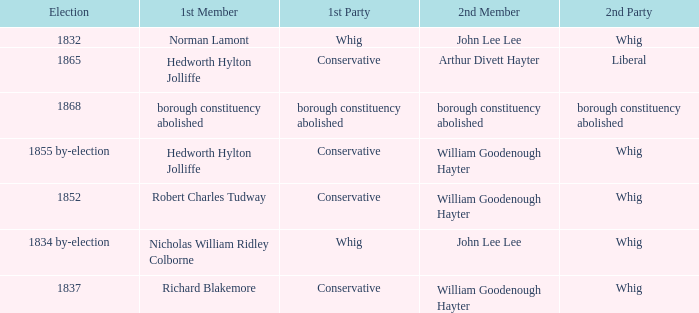Who's the conservative 1st member of the election of 1852? Robert Charles Tudway. I'm looking to parse the entire table for insights. Could you assist me with that? {'header': ['Election', '1st Member', '1st Party', '2nd Member', '2nd Party'], 'rows': [['1832', 'Norman Lamont', 'Whig', 'John Lee Lee', 'Whig'], ['1865', 'Hedworth Hylton Jolliffe', 'Conservative', 'Arthur Divett Hayter', 'Liberal'], ['1868', 'borough constituency abolished', 'borough constituency abolished', 'borough constituency abolished', 'borough constituency abolished'], ['1855 by-election', 'Hedworth Hylton Jolliffe', 'Conservative', 'William Goodenough Hayter', 'Whig'], ['1852', 'Robert Charles Tudway', 'Conservative', 'William Goodenough Hayter', 'Whig'], ['1834 by-election', 'Nicholas William Ridley Colborne', 'Whig', 'John Lee Lee', 'Whig'], ['1837', 'Richard Blakemore', 'Conservative', 'William Goodenough Hayter', 'Whig']]} 